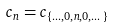Convert formula to latex. <formula><loc_0><loc_0><loc_500><loc_500>c _ { n } = c _ { \{ \dots , 0 , n , 0 , \dots \} }</formula> 